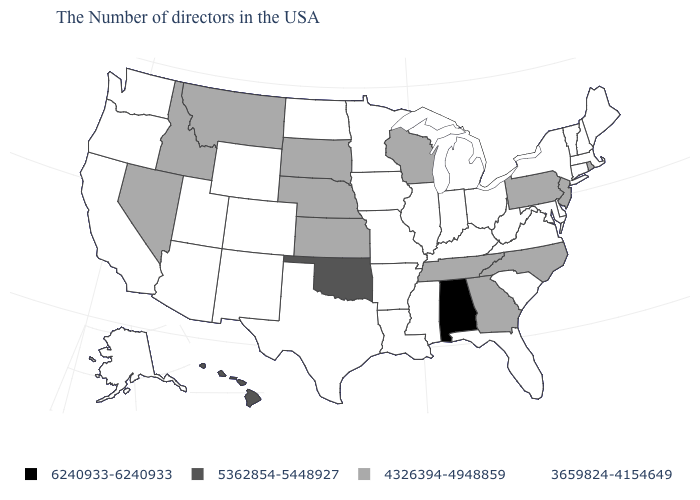Among the states that border Montana , which have the lowest value?
Concise answer only. North Dakota, Wyoming. What is the value of Hawaii?
Answer briefly. 5362854-5448927. Does the map have missing data?
Quick response, please. No. How many symbols are there in the legend?
Keep it brief. 4. Is the legend a continuous bar?
Answer briefly. No. Among the states that border Utah , does Nevada have the highest value?
Keep it brief. Yes. Among the states that border North Carolina , which have the lowest value?
Write a very short answer. Virginia, South Carolina. Is the legend a continuous bar?
Write a very short answer. No. Which states have the lowest value in the Northeast?
Be succinct. Maine, Massachusetts, New Hampshire, Vermont, Connecticut, New York. Which states hav the highest value in the MidWest?
Give a very brief answer. Wisconsin, Kansas, Nebraska, South Dakota. Among the states that border Indiana , which have the highest value?
Be succinct. Ohio, Michigan, Kentucky, Illinois. Name the states that have a value in the range 6240933-6240933?
Concise answer only. Alabama. Name the states that have a value in the range 6240933-6240933?
Be succinct. Alabama. What is the highest value in states that border Michigan?
Give a very brief answer. 4326394-4948859. Among the states that border Pennsylvania , which have the highest value?
Keep it brief. New Jersey. 